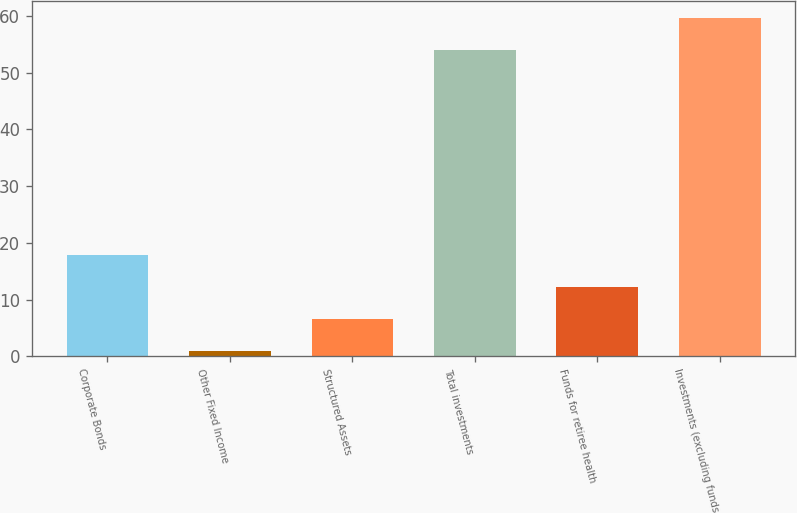Convert chart to OTSL. <chart><loc_0><loc_0><loc_500><loc_500><bar_chart><fcel>Corporate Bonds<fcel>Other Fixed Income<fcel>Structured Assets<fcel>Total investments<fcel>Funds for retiree health<fcel>Investments (excluding funds<nl><fcel>17.8<fcel>1<fcel>6.6<fcel>54<fcel>12.2<fcel>59.6<nl></chart> 